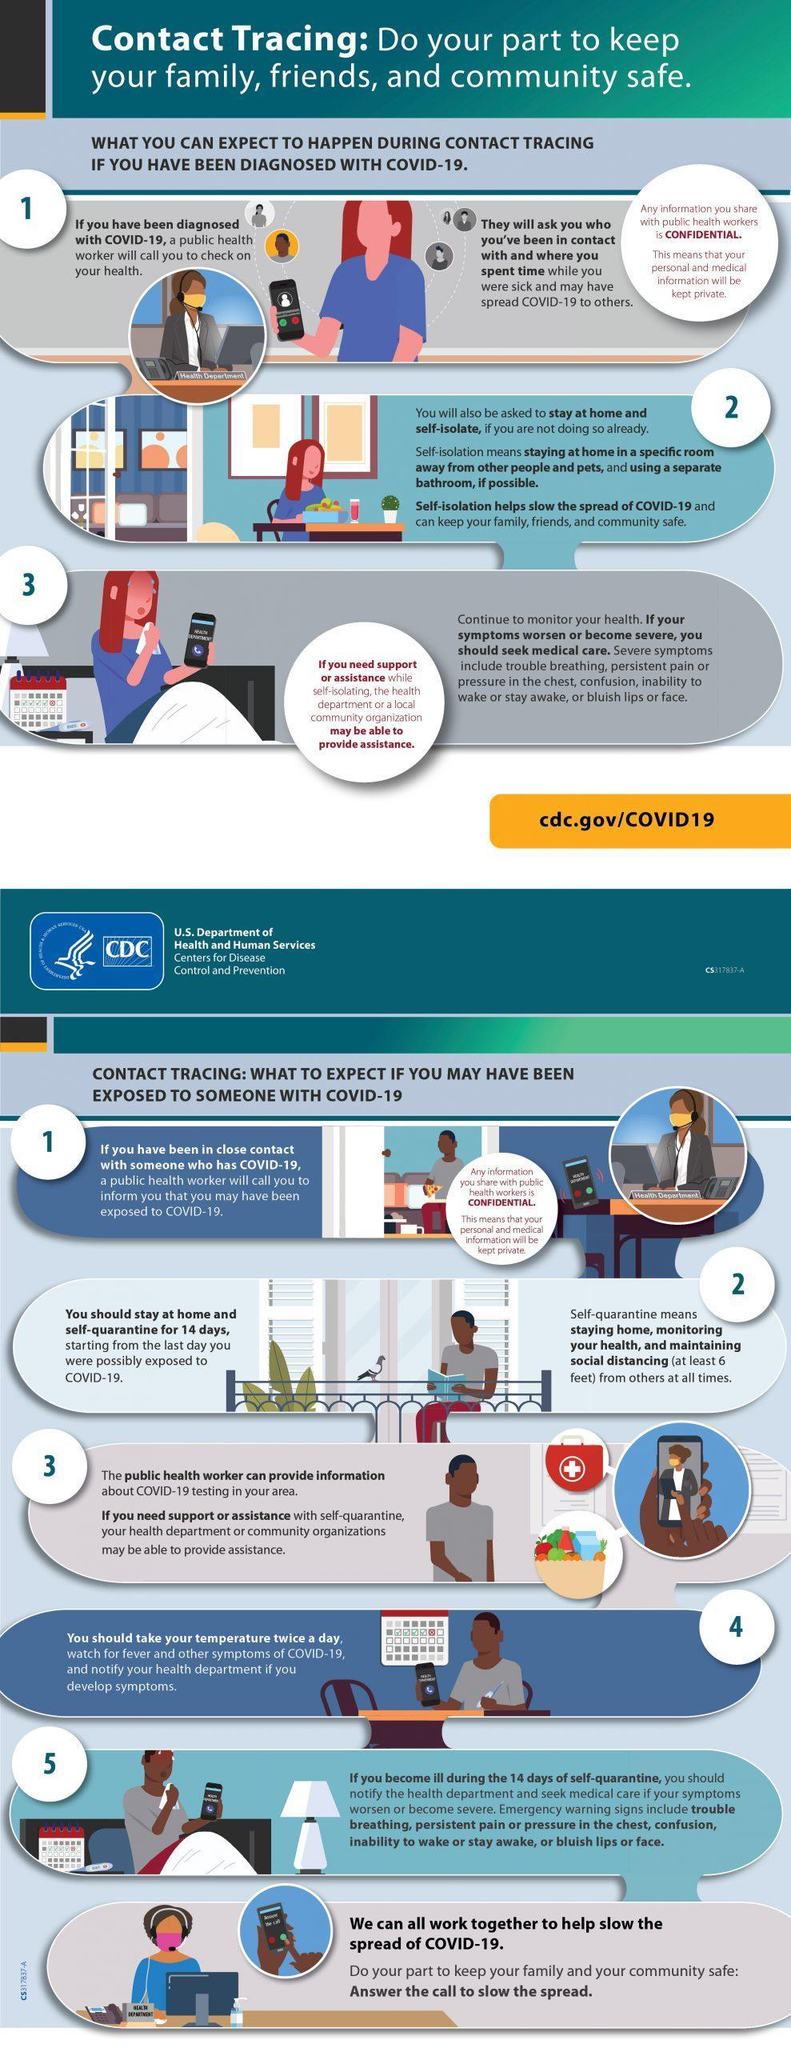How many mobile phones are in this infographic?
Answer the question with a short phrase. 7 How many people are sitting in front of the computer in this infographic? 3 How many calendars are in this infographic? 3 How many people wearing a mask are in this infographic? 4 